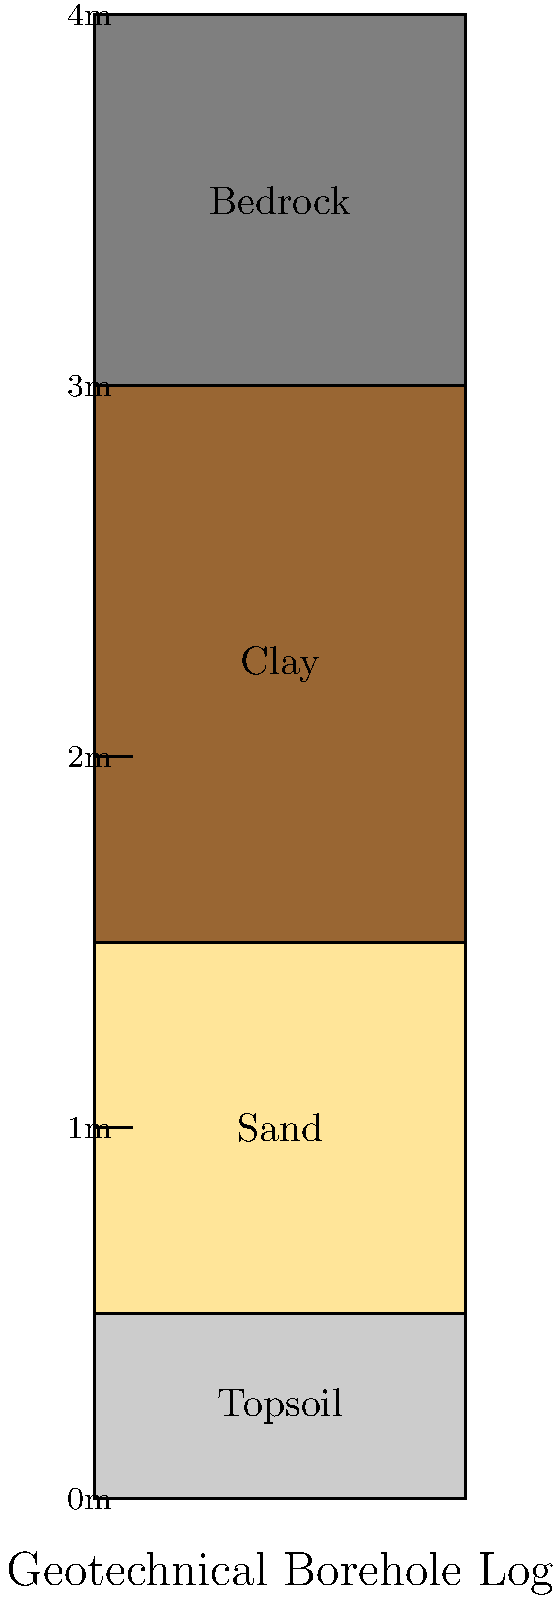As a proud parent viewing your child's artwork of a geotechnical borehole log, you notice four distinct soil layers. Which layer is most likely to have the highest permeability, and at what depth does it start? To answer this question, let's analyze the borehole log step-by-step:

1. The log shows four distinct layers:
   - Topsoil (0-0.5m)
   - Sand (0.5-1.5m)
   - Clay (1.5-3m)
   - Bedrock (3-4m)

2. Permeability refers to the ability of a material to allow water to flow through it. The permeability of different soil types, from highest to lowest, is generally:
   Sand > Silt > Clay > Bedrock

3. Among the layers shown in the borehole log:
   - Sand has the highest permeability due to its larger particle size and the spaces between particles.
   - Clay has very low permeability as its fine particles pack tightly together.
   - Topsoil can vary but is usually less permeable than sand.
   - Bedrock typically has very low permeability unless it's fractured.

4. Therefore, the sand layer is most likely to have the highest permeability.

5. The sand layer starts at a depth of 0.5m from the surface.
Answer: Sand, starting at 0.5m depth 